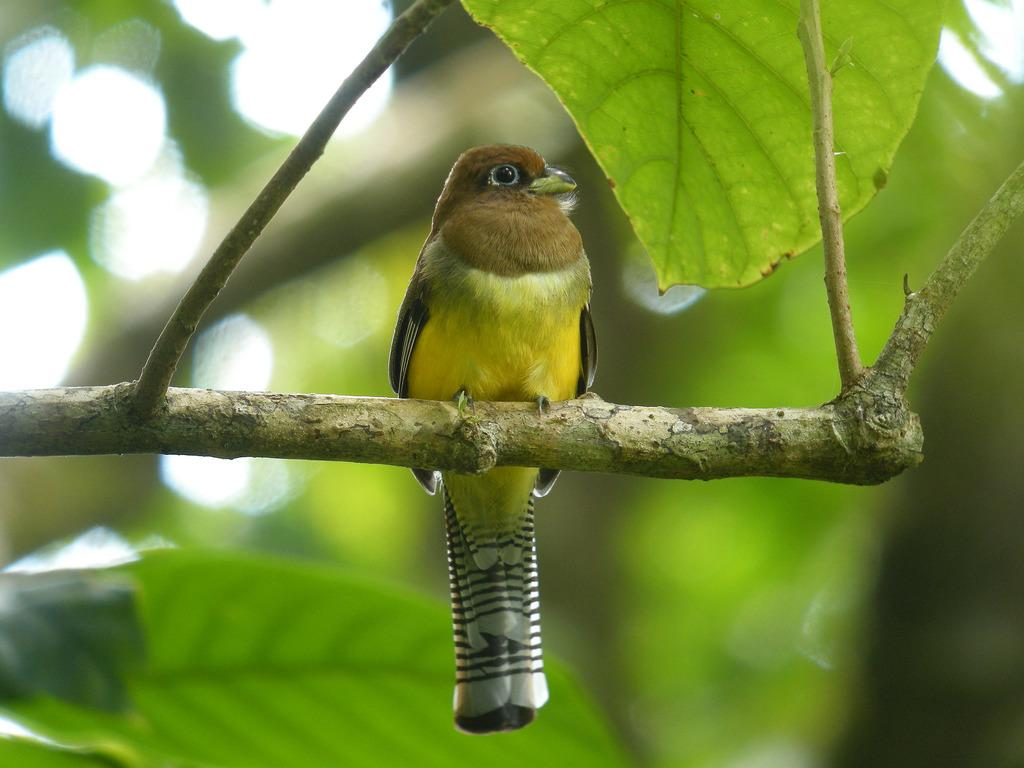What type of animal can be seen in the image? There is a bird in the image. Where is the bird located in the image? The bird is sitting on a stem. What can be seen in the background of the image? There are green leaves in the background of the image. What type of roof can be seen on the bird's suit in the image? There is no roof or suit present in the image; it features a bird sitting on a stem with green leaves in the background. 